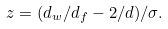Convert formula to latex. <formula><loc_0><loc_0><loc_500><loc_500>z = ( d _ { w } / d _ { f } - 2 / d ) / \sigma .</formula> 